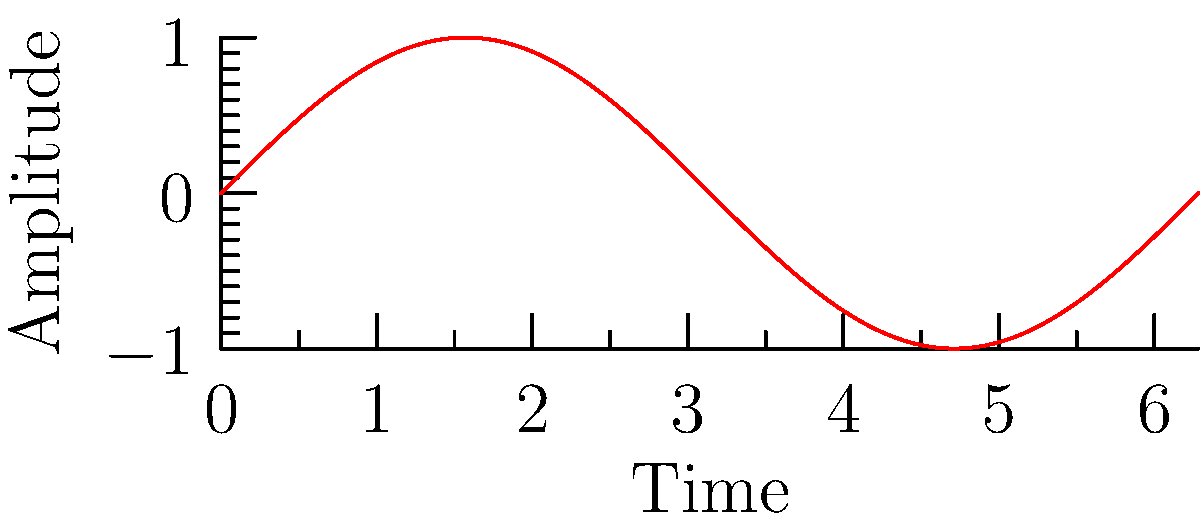Based on the audio waveform and frequency spectrum shown, which of the following characteristics is most likely present in this live performance recording?

A) High-frequency distortion
B) Low-frequency rumble
C) Balanced frequency response
D) Mid-range emphasis To interpret the audio waveform and frequency spectrum, let's analyze them step-by-step:

1. Time Domain (upper graph):
   - The waveform appears to be a clean sine wave.
   - There are no visible distortions or irregularities.
   - This suggests a pure tone or a well-balanced audio signal.

2. Frequency Domain (lower graph):
   - The spectrum shows a smooth curve that decreases exponentially.
   - There's a strong presence in the low-frequency range.
   - The high-frequency content gradually reduces.
   - This is typical of many natural sounds and well-recorded instruments.

3. Characteristics analysis:
   - High-frequency distortion would appear as spikes or elevated levels in the high-frequency range of the spectrum, which is not present.
   - Low-frequency rumble would show as irregular patterns in the time domain waveform and elevated levels at the very low end of the frequency spectrum, which is not evident.
   - Mid-range emphasis would appear as a bump or elevated region in the middle of the frequency spectrum, which is not observed.
   - The smooth, gradual decline in the frequency spectrum from low to high frequencies suggests a balanced frequency response.

Given these observations, the most likely characteristic present in this live performance recording is a balanced frequency response. This indicates that the audio wizard has successfully captured the performance without introducing unwanted artifacts or emphasizing any particular frequency range unnaturally.
Answer: C) Balanced frequency response 